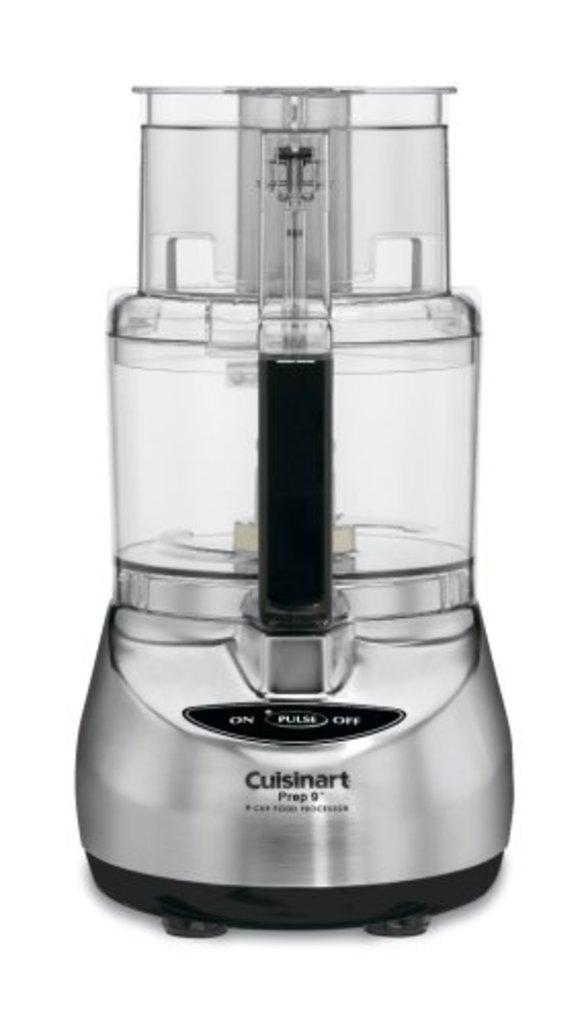Provide a one-sentence caption for the provided image. A Cuisinart appliance that has nothing in it. 